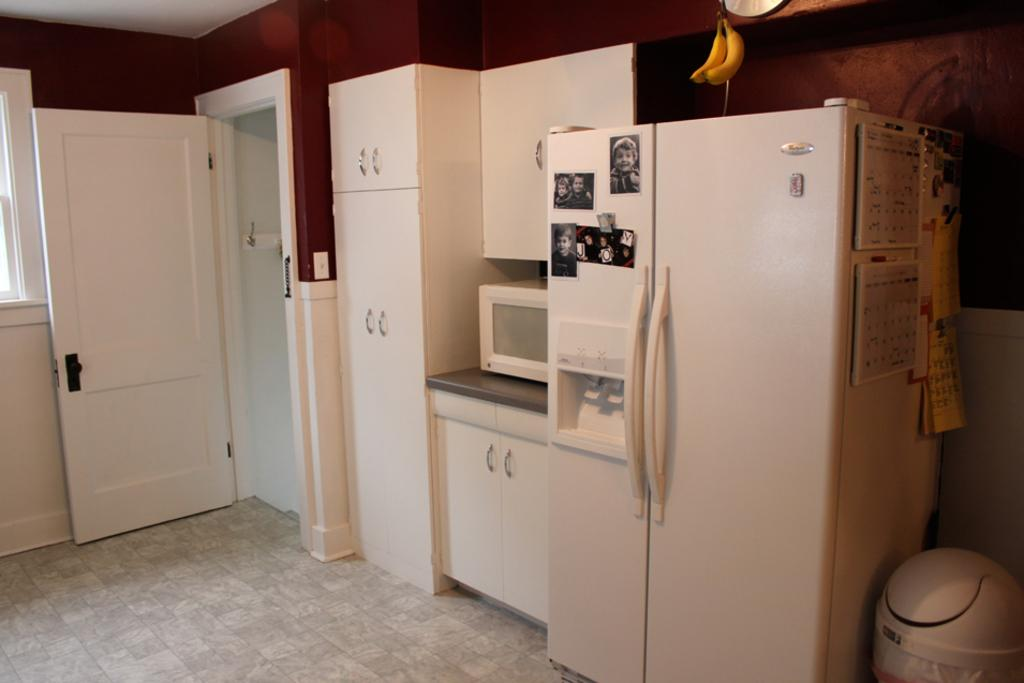What color is the door in the image? The door in the image is white. What type of furniture can be seen in the image? There are cupboards and a refrigerator in the image. What kitchen appliance is on a table in the image? There is a microwave on a table in the image. What type of food is visible on the floor in the image? Bananas are visible on the floor in the image. What other objects are on the floor in the image? There are other objects on the floor in the image. What type of humor is being displayed in the image? There is no humor present in the image; it is a scene of a kitchen with various appliances and objects. 